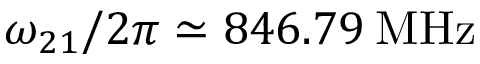Convert formula to latex. <formula><loc_0><loc_0><loc_500><loc_500>\omega _ { 2 1 } / 2 \pi \simeq 8 4 6 . 7 9 \, M H z</formula> 